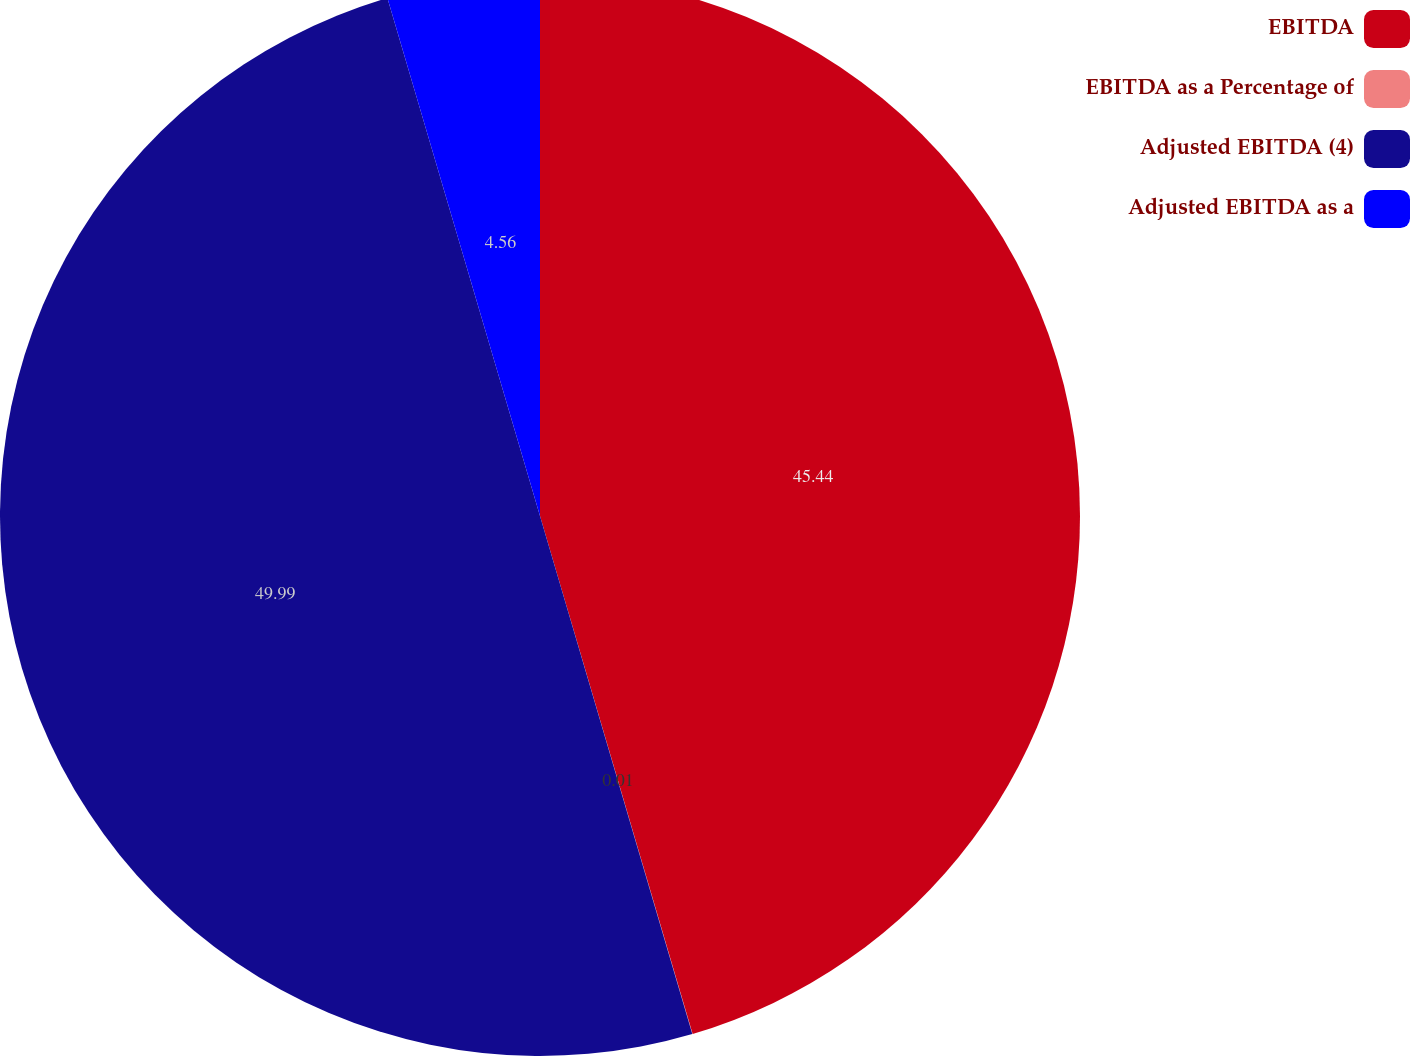Convert chart to OTSL. <chart><loc_0><loc_0><loc_500><loc_500><pie_chart><fcel>EBITDA<fcel>EBITDA as a Percentage of<fcel>Adjusted EBITDA (4)<fcel>Adjusted EBITDA as a<nl><fcel>45.44%<fcel>0.01%<fcel>49.99%<fcel>4.56%<nl></chart> 